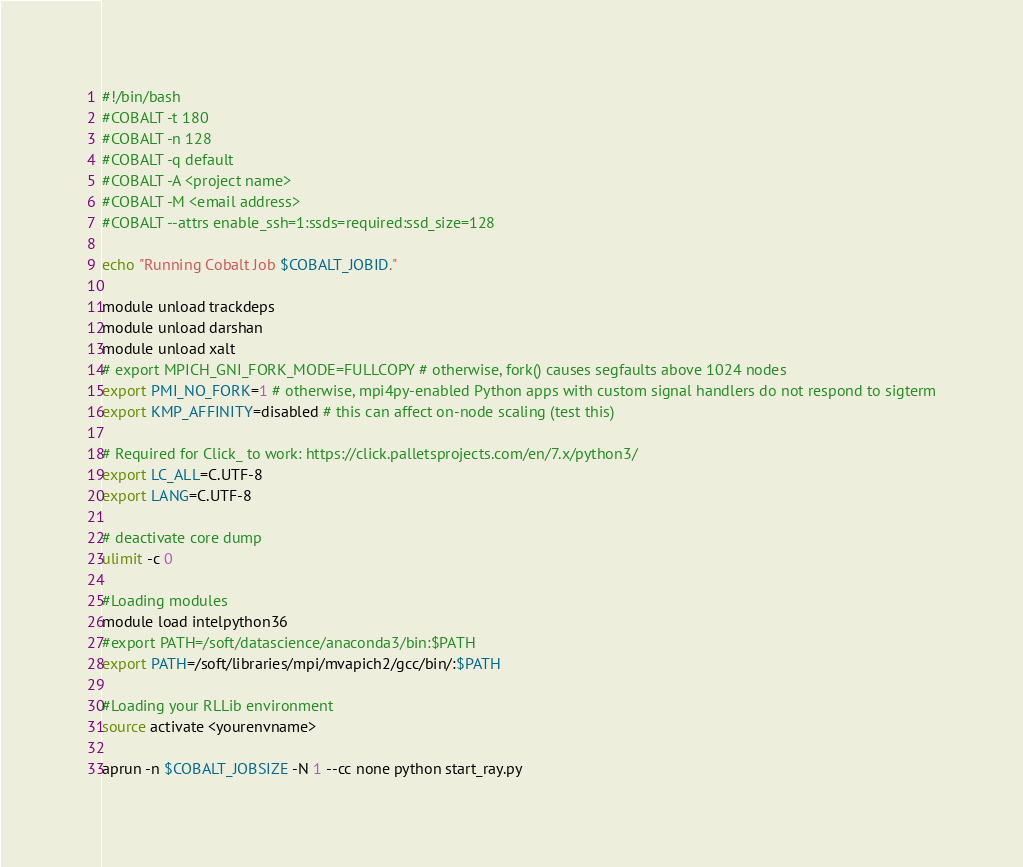Convert code to text. <code><loc_0><loc_0><loc_500><loc_500><_Bash_>#!/bin/bash
#COBALT -t 180
#COBALT -n 128
#COBALT -q default
#COBALT -A <project name>
#COBALT -M <email address>
#COBALT --attrs enable_ssh=1:ssds=required:ssd_size=128

echo "Running Cobalt Job $COBALT_JOBID."

module unload trackdeps
module unload darshan
module unload xalt
# export MPICH_GNI_FORK_MODE=FULLCOPY # otherwise, fork() causes segfaults above 1024 nodes
export PMI_NO_FORK=1 # otherwise, mpi4py-enabled Python apps with custom signal handlers do not respond to sigterm
export KMP_AFFINITY=disabled # this can affect on-node scaling (test this)

# Required for Click_ to work: https://click.palletsprojects.com/en/7.x/python3/
export LC_ALL=C.UTF-8
export LANG=C.UTF-8

# deactivate core dump
ulimit -c 0

#Loading modules
module load intelpython36
#export PATH=/soft/datascience/anaconda3/bin:$PATH
export PATH=/soft/libraries/mpi/mvapich2/gcc/bin/:$PATH

#Loading your RLLib environment
source activate <yourenvname>

aprun -n $COBALT_JOBSIZE -N 1 --cc none python start_ray.py
</code> 